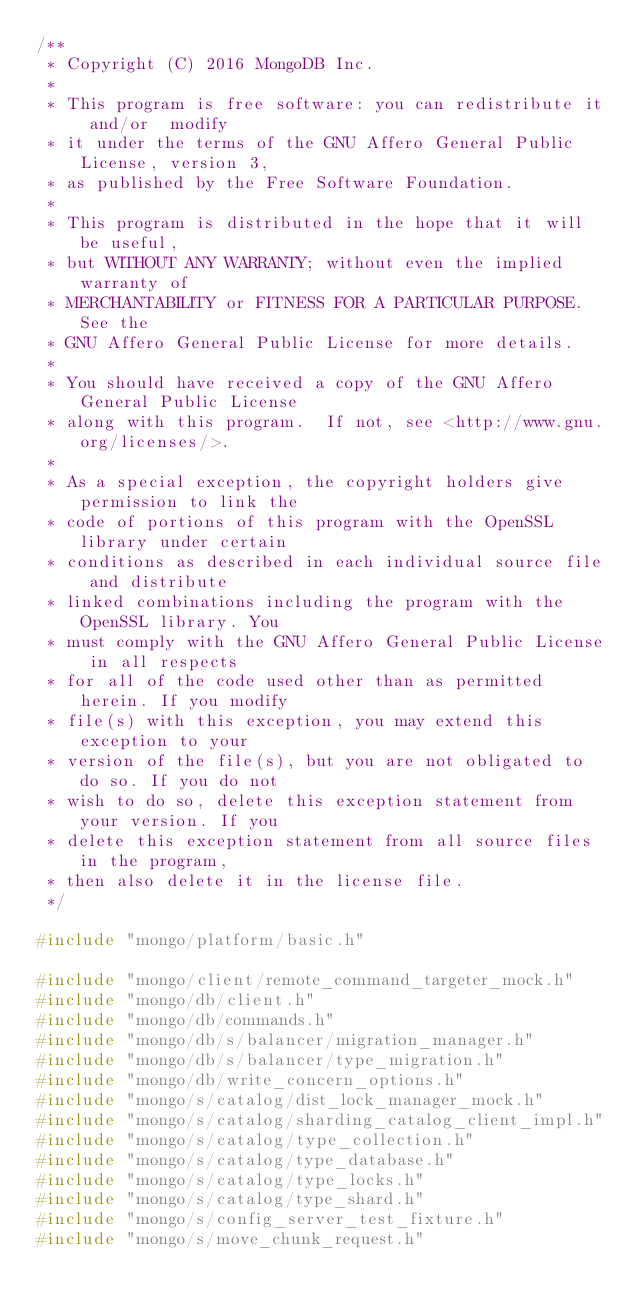Convert code to text. <code><loc_0><loc_0><loc_500><loc_500><_C++_>/**
 * Copyright (C) 2016 MongoDB Inc.
 *
 * This program is free software: you can redistribute it and/or  modify
 * it under the terms of the GNU Affero General Public License, version 3,
 * as published by the Free Software Foundation.
 *
 * This program is distributed in the hope that it will be useful,
 * but WITHOUT ANY WARRANTY; without even the implied warranty of
 * MERCHANTABILITY or FITNESS FOR A PARTICULAR PURPOSE.  See the
 * GNU Affero General Public License for more details.
 *
 * You should have received a copy of the GNU Affero General Public License
 * along with this program.  If not, see <http://www.gnu.org/licenses/>.
 *
 * As a special exception, the copyright holders give permission to link the
 * code of portions of this program with the OpenSSL library under certain
 * conditions as described in each individual source file and distribute
 * linked combinations including the program with the OpenSSL library. You
 * must comply with the GNU Affero General Public License in all respects
 * for all of the code used other than as permitted herein. If you modify
 * file(s) with this exception, you may extend this exception to your
 * version of the file(s), but you are not obligated to do so. If you do not
 * wish to do so, delete this exception statement from your version. If you
 * delete this exception statement from all source files in the program,
 * then also delete it in the license file.
 */

#include "mongo/platform/basic.h"

#include "mongo/client/remote_command_targeter_mock.h"
#include "mongo/db/client.h"
#include "mongo/db/commands.h"
#include "mongo/db/s/balancer/migration_manager.h"
#include "mongo/db/s/balancer/type_migration.h"
#include "mongo/db/write_concern_options.h"
#include "mongo/s/catalog/dist_lock_manager_mock.h"
#include "mongo/s/catalog/sharding_catalog_client_impl.h"
#include "mongo/s/catalog/type_collection.h"
#include "mongo/s/catalog/type_database.h"
#include "mongo/s/catalog/type_locks.h"
#include "mongo/s/catalog/type_shard.h"
#include "mongo/s/config_server_test_fixture.h"
#include "mongo/s/move_chunk_request.h"</code> 